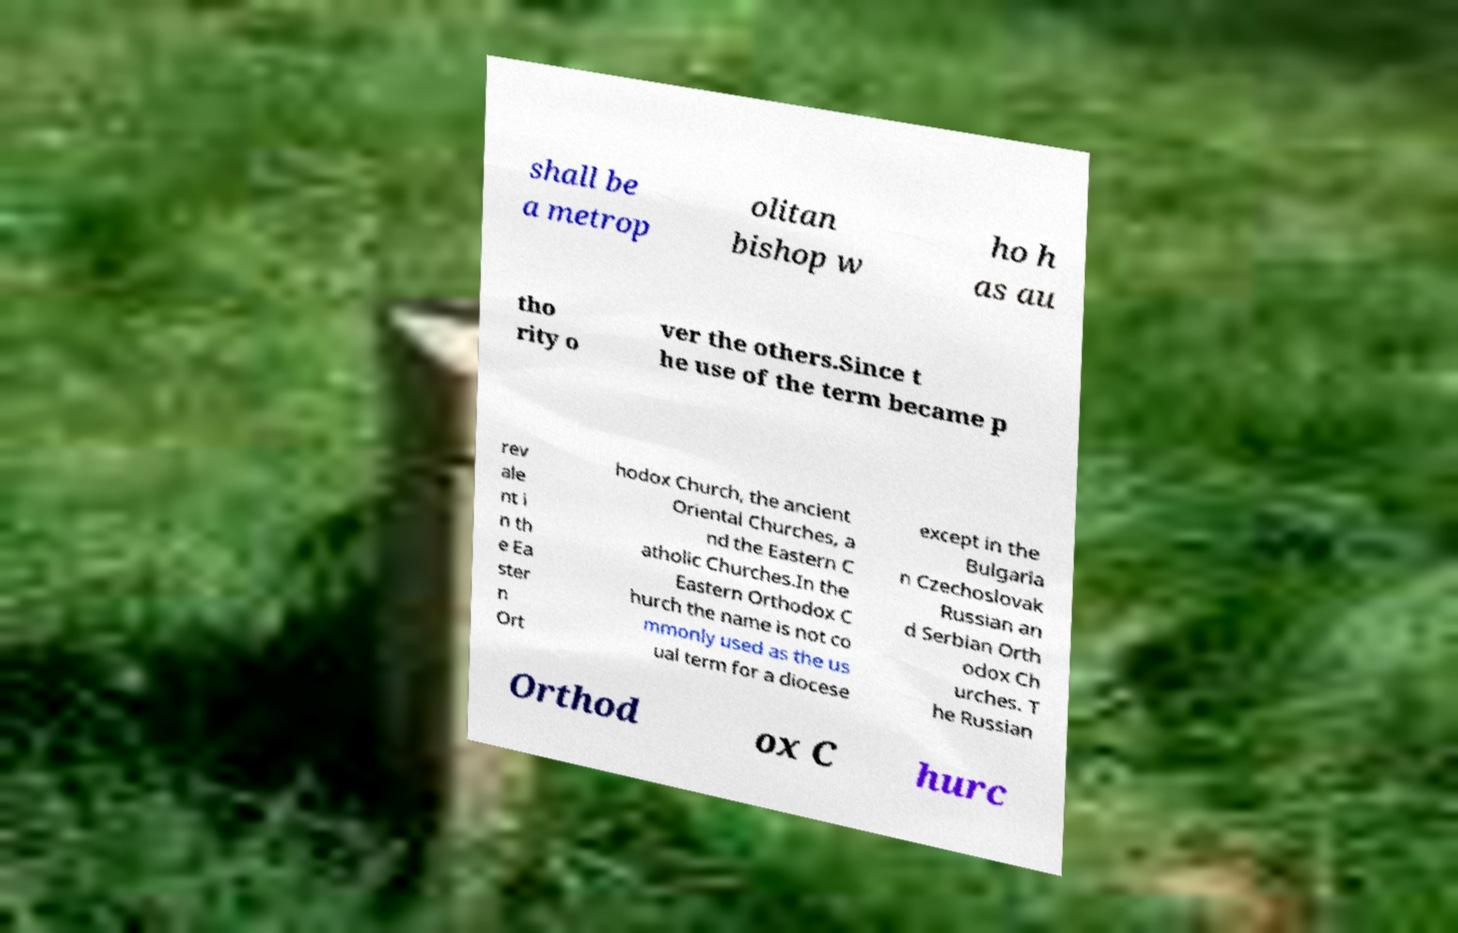Could you assist in decoding the text presented in this image and type it out clearly? shall be a metrop olitan bishop w ho h as au tho rity o ver the others.Since t he use of the term became p rev ale nt i n th e Ea ster n Ort hodox Church, the ancient Oriental Churches, a nd the Eastern C atholic Churches.In the Eastern Orthodox C hurch the name is not co mmonly used as the us ual term for a diocese except in the Bulgaria n Czechoslovak Russian an d Serbian Orth odox Ch urches. T he Russian Orthod ox C hurc 